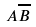Convert formula to latex. <formula><loc_0><loc_0><loc_500><loc_500>A \overline { B }</formula> 